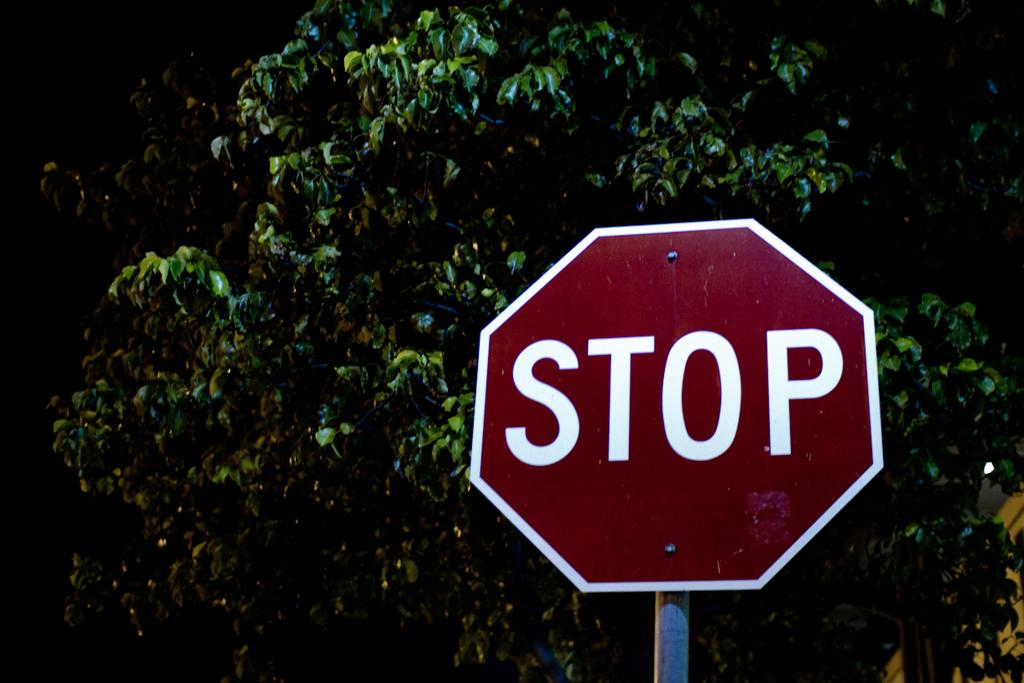<image>
Offer a succinct explanation of the picture presented. A red stop sign is mounted to a metal post. 